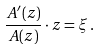Convert formula to latex. <formula><loc_0><loc_0><loc_500><loc_500>\frac { A ^ { \prime } ( z ) } { A ( z ) } \cdot z = \xi \, .</formula> 